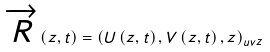Convert formula to latex. <formula><loc_0><loc_0><loc_500><loc_500>\overrightarrow { R } \left ( z , t \right ) = \left ( U \left ( z , t \right ) , V \left ( z , t \right ) , z \right ) _ { u v z }</formula> 